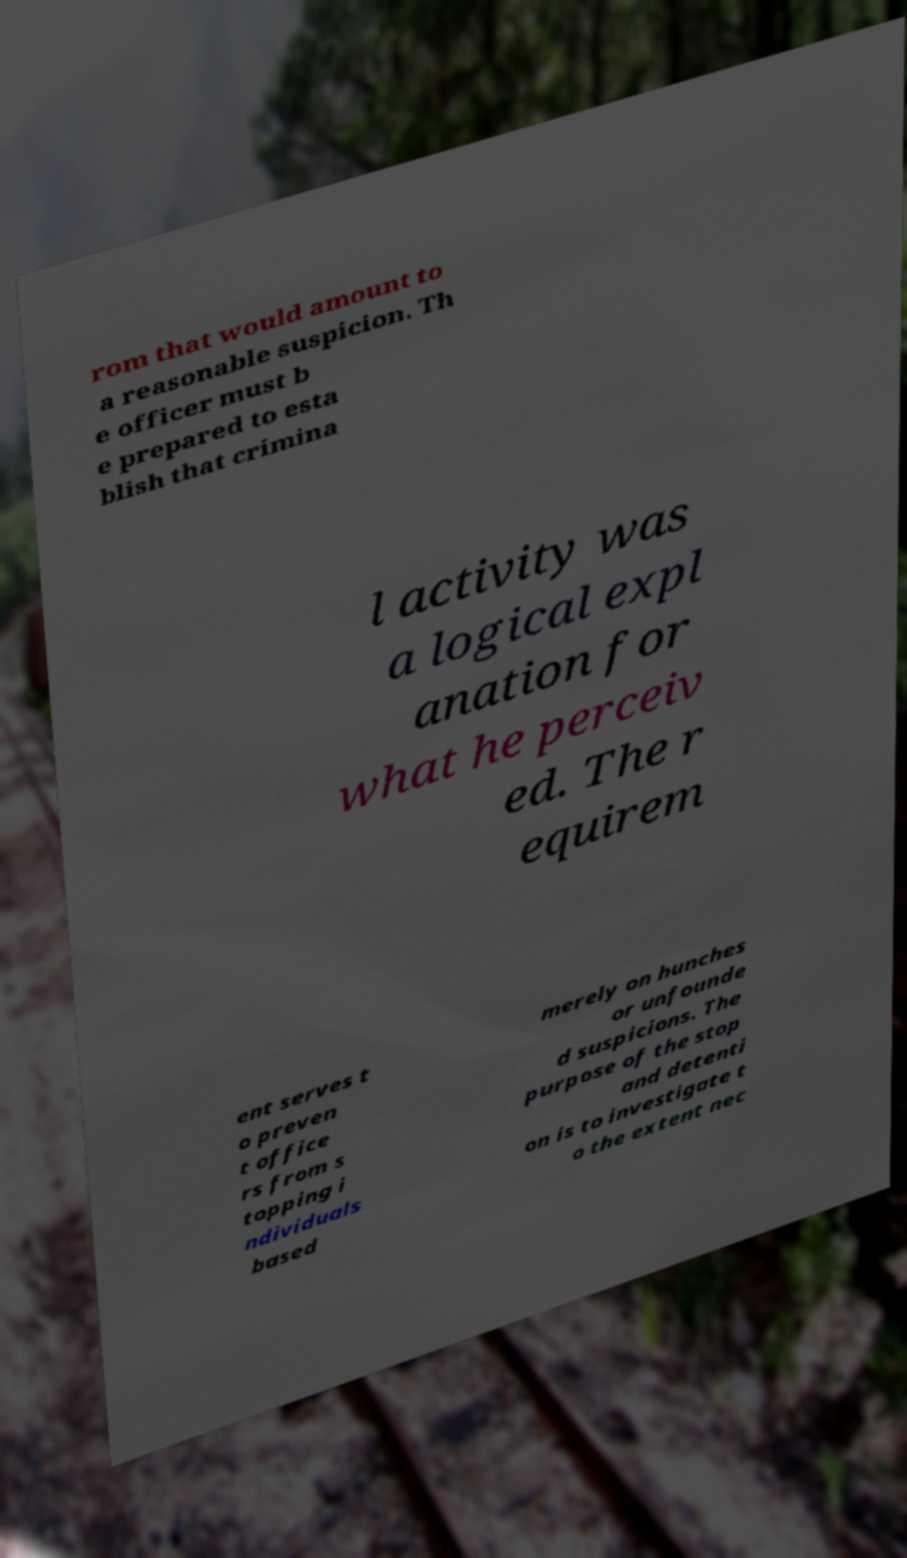I need the written content from this picture converted into text. Can you do that? rom that would amount to a reasonable suspicion. Th e officer must b e prepared to esta blish that crimina l activity was a logical expl anation for what he perceiv ed. The r equirem ent serves t o preven t office rs from s topping i ndividuals based merely on hunches or unfounde d suspicions. The purpose of the stop and detenti on is to investigate t o the extent nec 